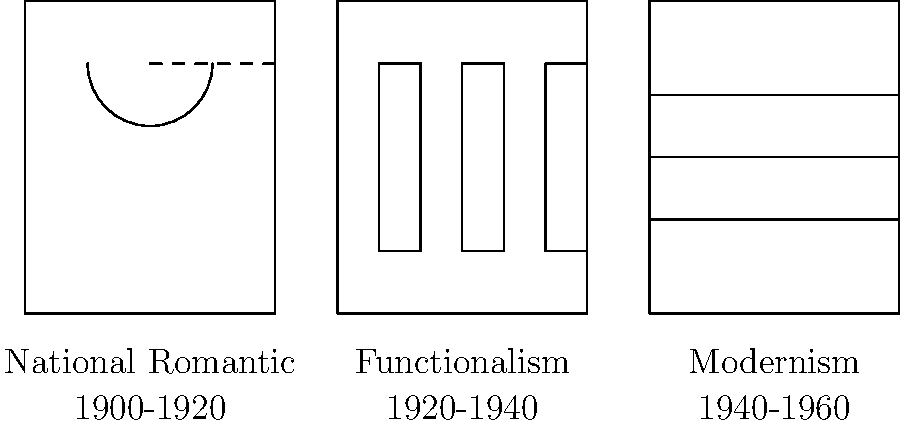Match the following Finnish architectural styles to their corresponding time periods based on the facade illustrations provided:

A. National Romantic
B. Functionalism
C. Modernism

1. 1900-1920
2. 1920-1940
3. 1940-1960 To match Finnish architectural styles to their corresponding time periods, we need to analyze the characteristics of each facade and relate them to historical context:

1. National Romantic (1900-1920):
   - Features curved lines and organic forms
   - Often incorporates elements inspired by nature and Finnish folklore
   - The illustration shows an arched window, typical of this style

2. Functionalism (1920-1940):
   - Emphasizes clean lines and geometric shapes
   - Focuses on functionality over ornamentation
   - The facade shows regular, rectangular windows without decorative elements

3. Modernism (1940-1960):
   - Characterized by simplicity and minimalism
   - Often features large, horizontal windows
   - The illustration depicts a wide, horizontal window spanning the facade

By matching these characteristics to the illustrations and considering the chronological order of architectural movements in Finland, we can determine the correct pairings:

A. National Romantic - 1 (1900-1920)
B. Functionalism - 2 (1920-1940)
C. Modernism - 3 (1940-1960)
Answer: A1, B2, C3 